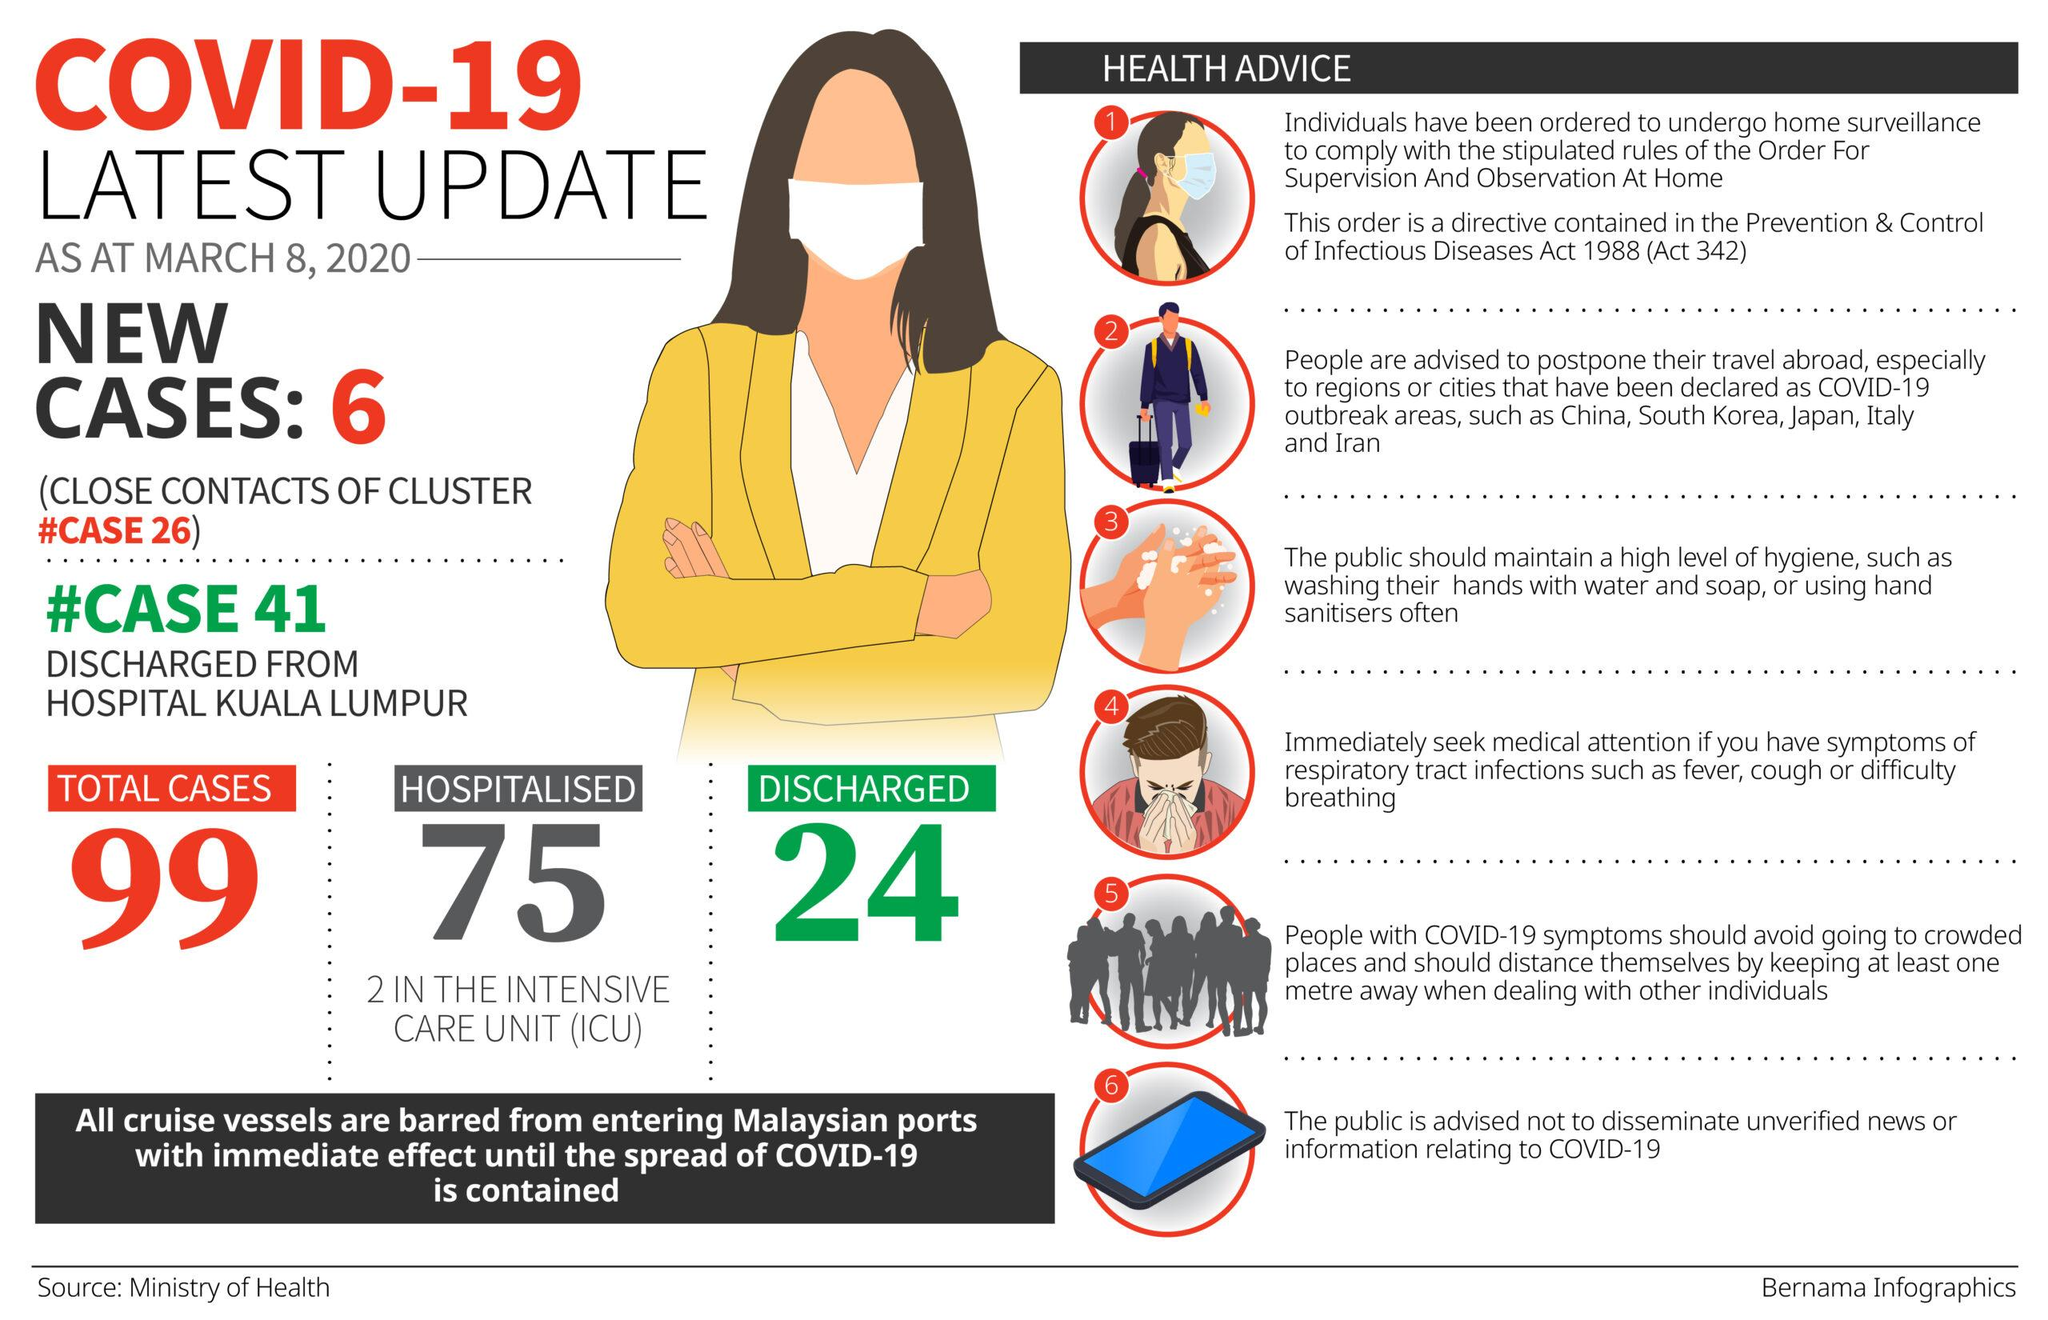Draw attention to some important aspects in this diagram. As of March 8, 2020, there were 2 COVID-19 cases in Malaysia that were admitted to the ICU. As of March 8, 2020, a total of 6 new cases of Covid-19 were reported in Malaysia. As of March 8, 2020, Malaysia reported 24 cases of COVID-19 recovery. As of March 8, 2020, a total of 75 COVID-19 patients were hospitalized in Malaysia. As of March 8, 2020, the total number of COVID-19 cases reported in Malaysia was 99. 